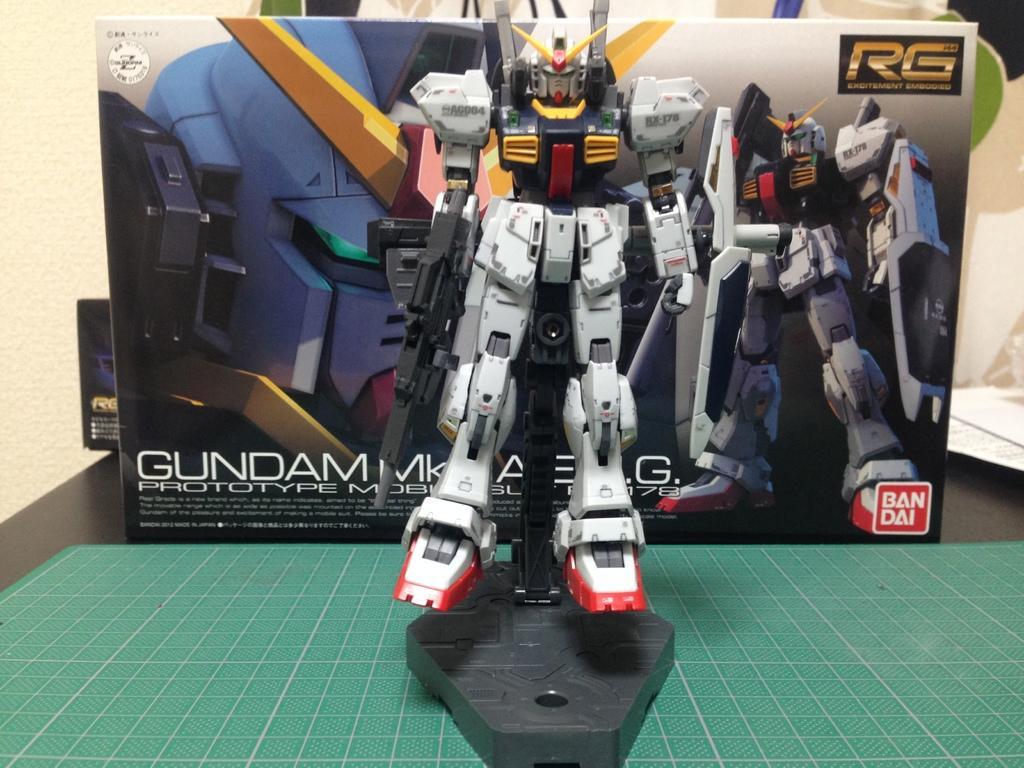Please provide a concise description of this image. In this image I can see a robot toy which is white, red, black and yellow in color on the green colored object. In the background I can see the box and the cream colored wall. 